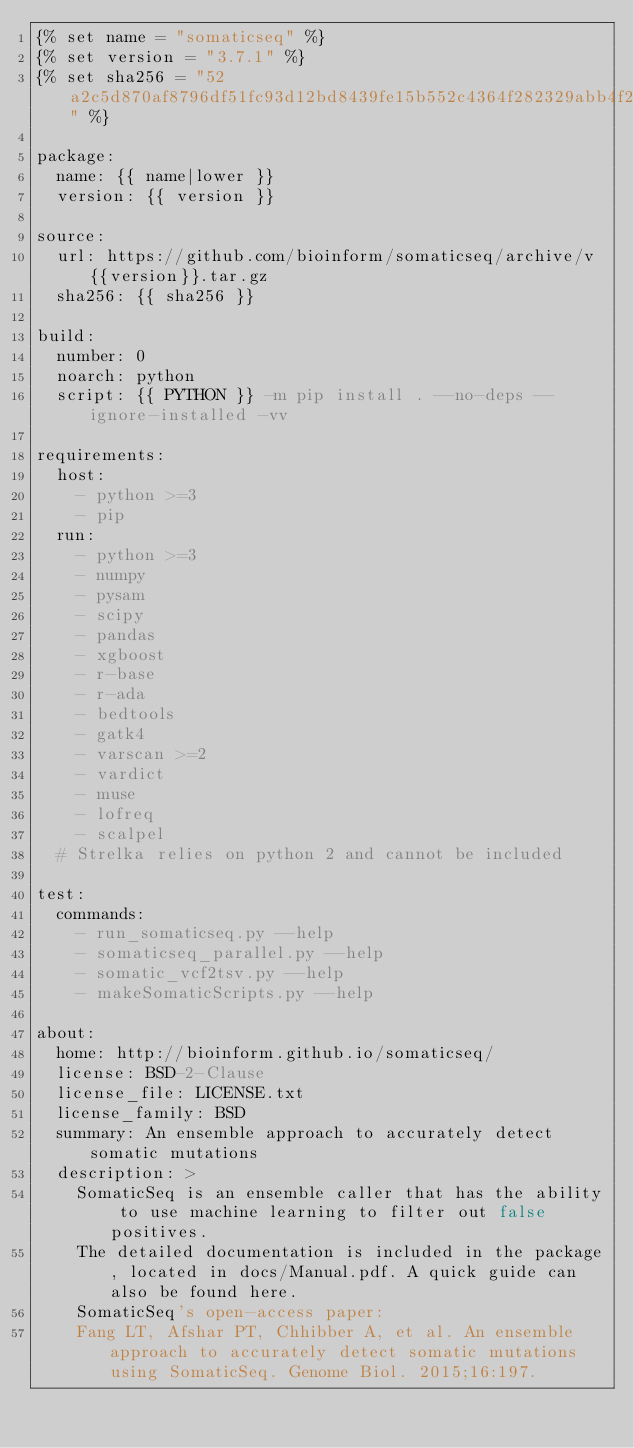Convert code to text. <code><loc_0><loc_0><loc_500><loc_500><_YAML_>{% set name = "somaticseq" %}
{% set version = "3.7.1" %}
{% set sha256 = "52a2c5d870af8796df51fc93d12bd8439fe15b552c4364f282329abb4f28d773" %}

package:
  name: {{ name|lower }}
  version: {{ version }}

source:
  url: https://github.com/bioinform/somaticseq/archive/v{{version}}.tar.gz
  sha256: {{ sha256 }}

build:
  number: 0
  noarch: python
  script: {{ PYTHON }} -m pip install . --no-deps --ignore-installed -vv

requirements:
  host:
    - python >=3
    - pip
  run:
    - python >=3
    - numpy
    - pysam
    - scipy
    - pandas
    - xgboost
    - r-base
    - r-ada
    - bedtools
    - gatk4
    - varscan >=2
    - vardict
    - muse
    - lofreq
    - scalpel
  # Strelka relies on python 2 and cannot be included

test:
  commands:
    - run_somaticseq.py --help
    - somaticseq_parallel.py --help
    - somatic_vcf2tsv.py --help
    - makeSomaticScripts.py --help

about:
  home: http://bioinform.github.io/somaticseq/
  license: BSD-2-Clause
  license_file: LICENSE.txt
  license_family: BSD
  summary: An ensemble approach to accurately detect somatic mutations
  description: >
    SomaticSeq is an ensemble caller that has the ability to use machine learning to filter out false positives.
    The detailed documentation is included in the package, located in docs/Manual.pdf. A quick guide can also be found here.
    SomaticSeq's open-access paper:
    Fang LT, Afshar PT, Chhibber A, et al. An ensemble approach to accurately detect somatic mutations using SomaticSeq. Genome Biol. 2015;16:197.
</code> 